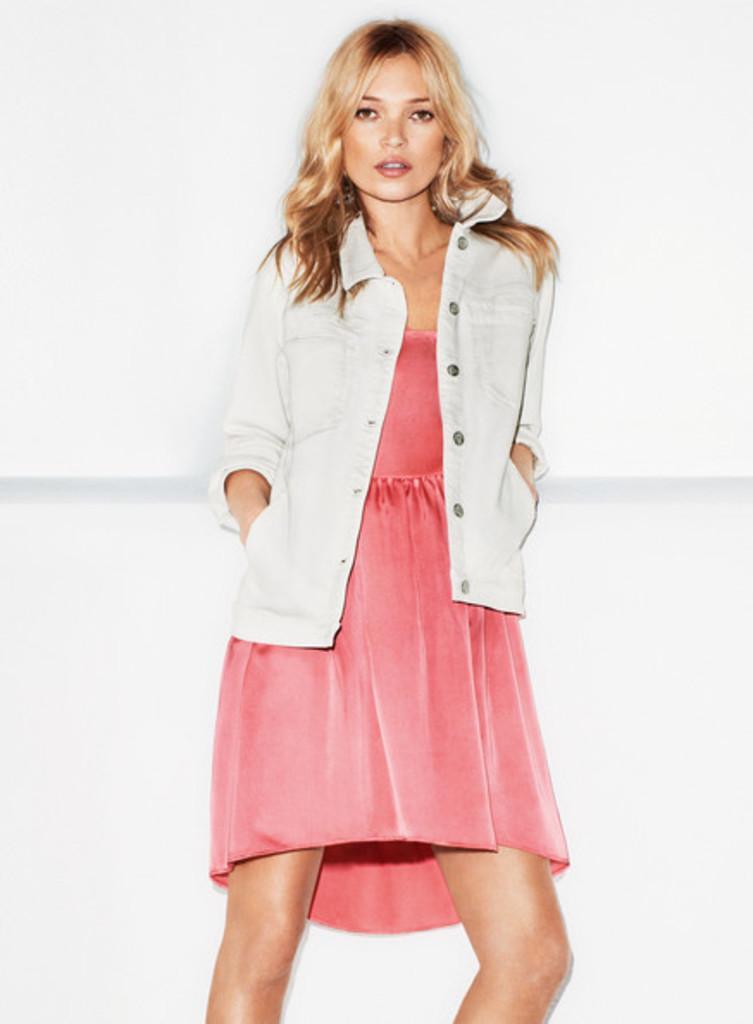Can you describe this image briefly? In the center of the image there is a woman standing. In the background we can see wall. 